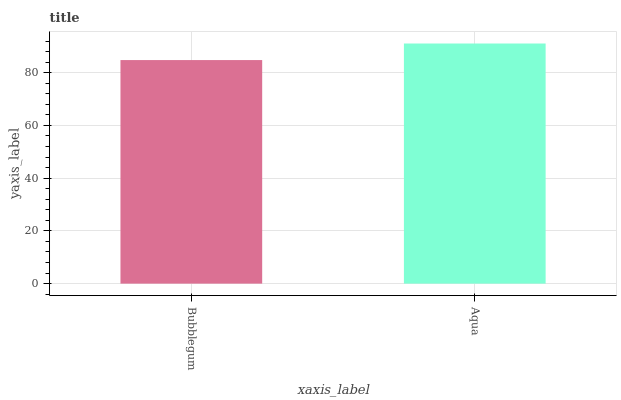Is Bubblegum the minimum?
Answer yes or no. Yes. Is Aqua the maximum?
Answer yes or no. Yes. Is Aqua the minimum?
Answer yes or no. No. Is Aqua greater than Bubblegum?
Answer yes or no. Yes. Is Bubblegum less than Aqua?
Answer yes or no. Yes. Is Bubblegum greater than Aqua?
Answer yes or no. No. Is Aqua less than Bubblegum?
Answer yes or no. No. Is Aqua the high median?
Answer yes or no. Yes. Is Bubblegum the low median?
Answer yes or no. Yes. Is Bubblegum the high median?
Answer yes or no. No. Is Aqua the low median?
Answer yes or no. No. 